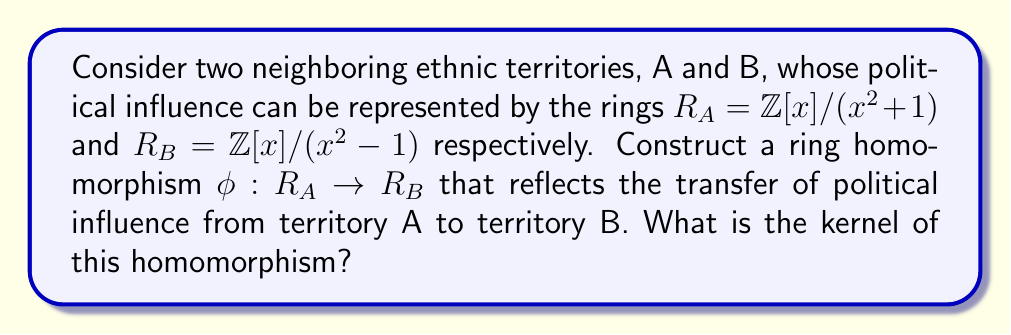Provide a solution to this math problem. To solve this problem, we need to follow these steps:

1) First, let's understand what these rings represent:
   $R_A = \mathbb{Z}[x]/(x^2+1)$ means polynomials over integers modulo $x^2+1$
   $R_B = \mathbb{Z}[x]/(x^2-1)$ means polynomials over integers modulo $x^2-1$

2) To construct a homomorphism, we need to define $\phi(x)$ in $R_B$ such that it preserves the ring structure.

3) Let's try $\phi(x) = x$. We need to check if this preserves the defining relation of $R_A$:

   $\phi(x^2+1) = \phi(x)^2 + \phi(1) = x^2 + 1$

   In $R_B$, $x^2 \equiv 1$, so $x^2 + 1 \equiv 1 + 1 \equiv 2 \not\equiv 0$

4) Let's try $\phi(x) = x+1$ instead:

   $\phi(x^2+1) = \phi(x)^2 + \phi(1) = (x+1)^2 + 1 = x^2 + 2x + 1 + 1 = x^2 + 2x + 2$

   In $R_B$, $x^2 \equiv 1$, so $x^2 + 2x + 2 \equiv 1 + 2x + 2 \equiv 2x + 3 \not\equiv 0$

5) Finally, let's try $\phi(x) = x-1$:

   $\phi(x^2+1) = \phi(x)^2 + \phi(1) = (x-1)^2 + 1 = x^2 - 2x + 1 + 1 = x^2 - 2x + 2$

   In $R_B$, $x^2 \equiv 1$, so $x^2 - 2x + 2 \equiv 1 - 2x + 2 \equiv -2x + 3 \equiv 0$

6) Therefore, $\phi(x) = x-1$ defines a valid ring homomorphism from $R_A$ to $R_B$.

7) To find the kernel, we need to find all elements $a + bx \in R_A$ such that $\phi(a + bx) = 0$ in $R_B$:

   $\phi(a + bx) = a + b(x-1) = a - b + bx$

   This is zero in $R_B$ if and only if $a - b \equiv 0 \pmod{2}$ and $b \equiv 0 \pmod{2}$.

8) Therefore, the kernel consists of elements of the form $2k + 2kx$ where $k \in \mathbb{Z}$.
Answer: The kernel of the homomorphism $\phi: R_A \rightarrow R_B$ defined by $\phi(x) = x-1$ is $\{2k + 2kx : k \in \mathbb{Z}\}$. 